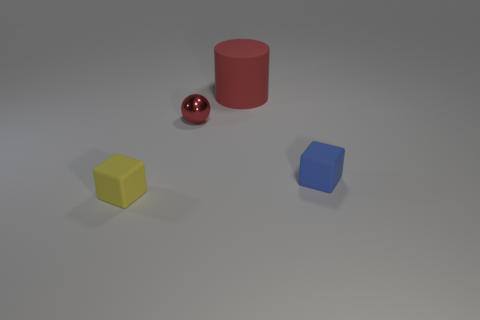Can you describe the shapes visible in the picture? Certainly! In the image, there are four distinct shapes: a sphere represented by the red ball, a cube by the blue object, a cylinder by the red one, and a cube with a slightly less defined shape due to its perspective, represented by the yellow object. 